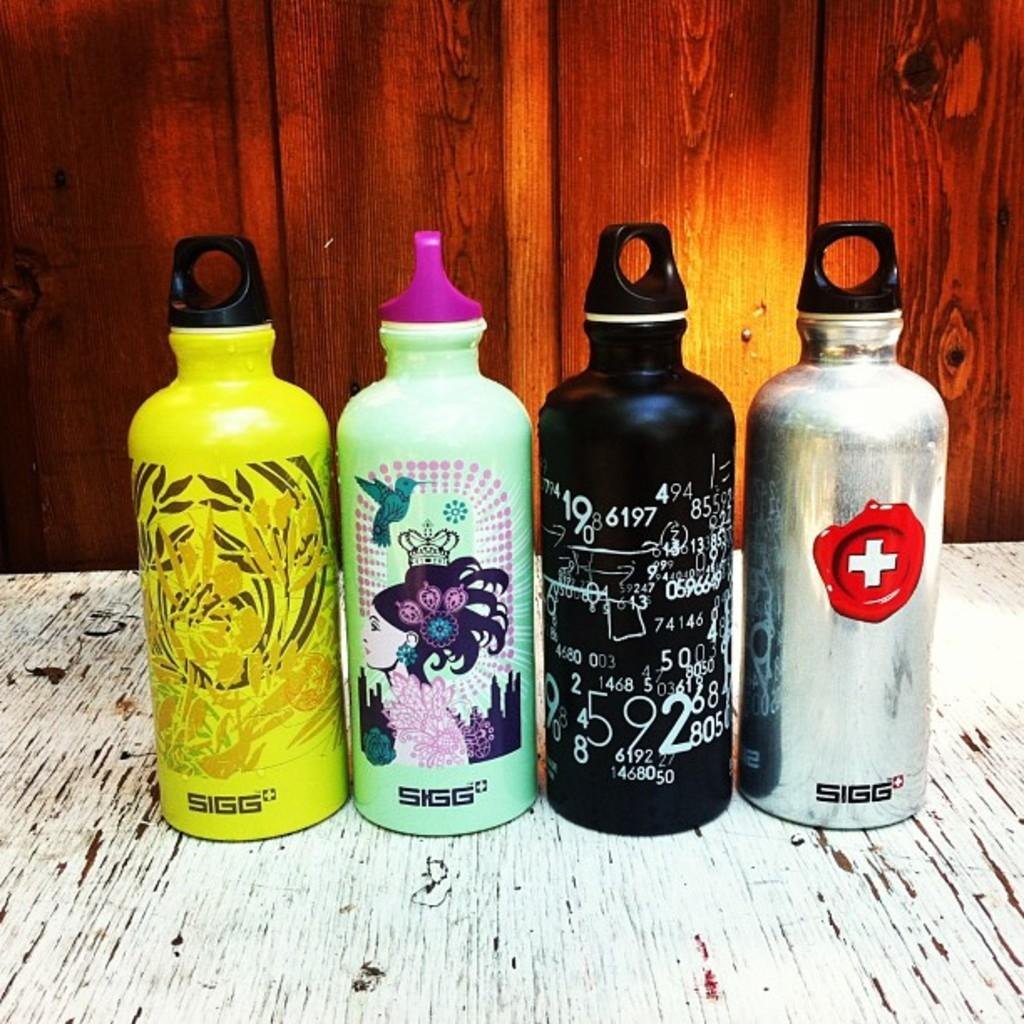<image>
Give a short and clear explanation of the subsequent image. Four SIGG water bottles side by side on a table. 